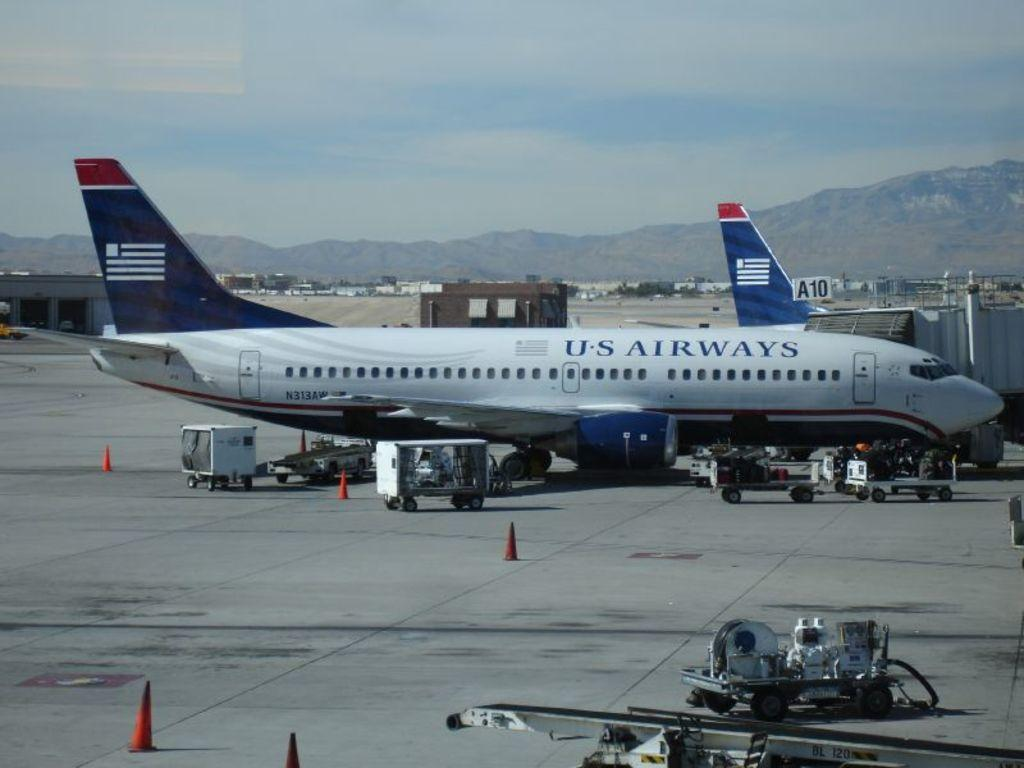<image>
Describe the image concisely. a US airways plane is being loaded for takeoff 